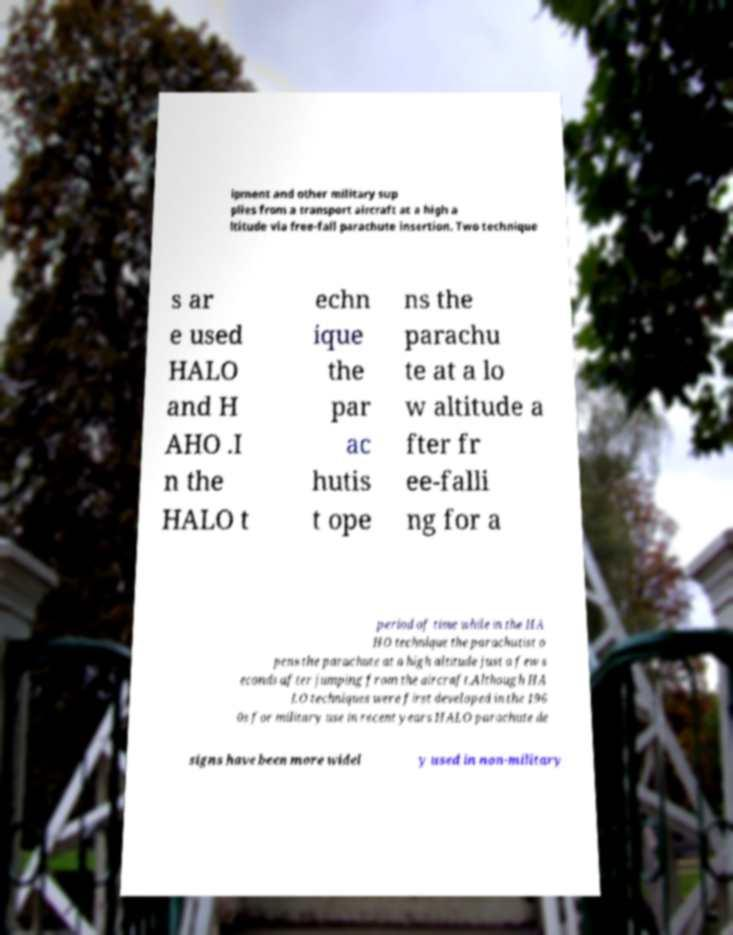Could you extract and type out the text from this image? ipment and other military sup plies from a transport aircraft at a high a ltitude via free-fall parachute insertion. Two technique s ar e used HALO and H AHO .I n the HALO t echn ique the par ac hutis t ope ns the parachu te at a lo w altitude a fter fr ee-falli ng for a period of time while in the HA HO technique the parachutist o pens the parachute at a high altitude just a few s econds after jumping from the aircraft.Although HA LO techniques were first developed in the 196 0s for military use in recent years HALO parachute de signs have been more widel y used in non-military 